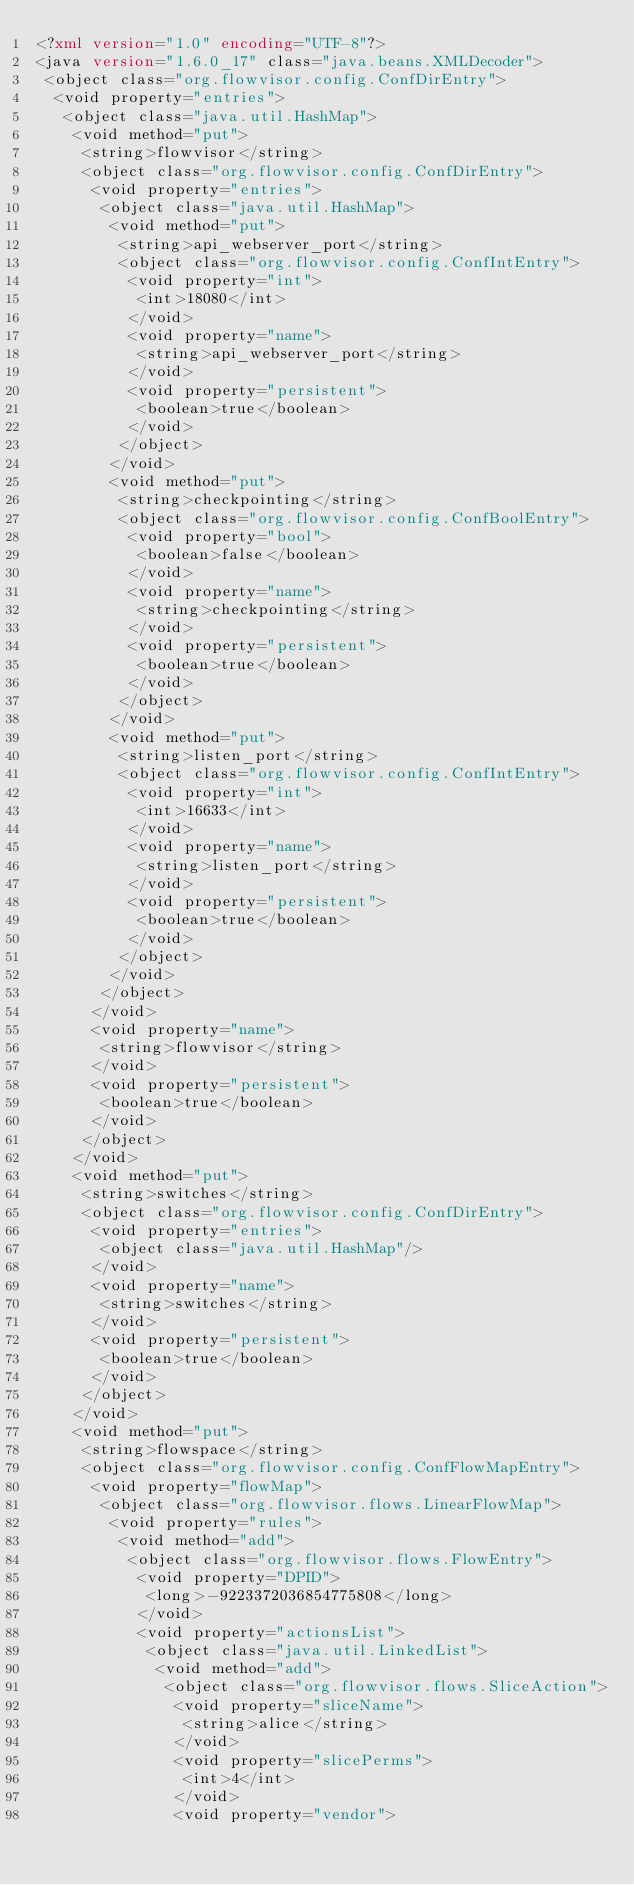Convert code to text. <code><loc_0><loc_0><loc_500><loc_500><_XML_><?xml version="1.0" encoding="UTF-8"?> 
<java version="1.6.0_17" class="java.beans.XMLDecoder"> 
 <object class="org.flowvisor.config.ConfDirEntry"> 
  <void property="entries"> 
   <object class="java.util.HashMap"> 
    <void method="put"> 
     <string>flowvisor</string> 
     <object class="org.flowvisor.config.ConfDirEntry"> 
      <void property="entries"> 
       <object class="java.util.HashMap"> 
        <void method="put"> 
         <string>api_webserver_port</string> 
         <object class="org.flowvisor.config.ConfIntEntry"> 
          <void property="int"> 
           <int>18080</int> 
          </void> 
          <void property="name"> 
           <string>api_webserver_port</string> 
          </void> 
          <void property="persistent"> 
           <boolean>true</boolean> 
          </void> 
         </object> 
        </void> 
        <void method="put"> 
         <string>checkpointing</string> 
         <object class="org.flowvisor.config.ConfBoolEntry"> 
          <void property="bool"> 
           <boolean>false</boolean> 
          </void> 
          <void property="name"> 
           <string>checkpointing</string> 
          </void> 
          <void property="persistent"> 
           <boolean>true</boolean> 
          </void> 
         </object> 
        </void> 
        <void method="put"> 
         <string>listen_port</string> 
         <object class="org.flowvisor.config.ConfIntEntry"> 
          <void property="int"> 
           <int>16633</int> 
          </void> 
          <void property="name"> 
           <string>listen_port</string> 
          </void> 
          <void property="persistent"> 
           <boolean>true</boolean> 
          </void> 
         </object> 
        </void> 
       </object> 
      </void> 
      <void property="name"> 
       <string>flowvisor</string> 
      </void> 
      <void property="persistent"> 
       <boolean>true</boolean> 
      </void> 
     </object> 
    </void> 
    <void method="put"> 
     <string>switches</string> 
     <object class="org.flowvisor.config.ConfDirEntry"> 
      <void property="entries"> 
       <object class="java.util.HashMap"/> 
      </void> 
      <void property="name"> 
       <string>switches</string> 
      </void> 
      <void property="persistent"> 
       <boolean>true</boolean> 
      </void> 
     </object> 
    </void> 
    <void method="put"> 
     <string>flowspace</string> 
     <object class="org.flowvisor.config.ConfFlowMapEntry"> 
      <void property="flowMap"> 
       <object class="org.flowvisor.flows.LinearFlowMap"> 
        <void property="rules"> 
         <void method="add"> 
          <object class="org.flowvisor.flows.FlowEntry"> 
           <void property="DPID"> 
            <long>-9223372036854775808</long> 
           </void> 
           <void property="actionsList"> 
            <object class="java.util.LinkedList"> 
             <void method="add"> 
              <object class="org.flowvisor.flows.SliceAction"> 
               <void property="sliceName"> 
                <string>alice</string> 
               </void> 
               <void property="slicePerms"> 
                <int>4</int> 
               </void> 
               <void property="vendor"> </code> 